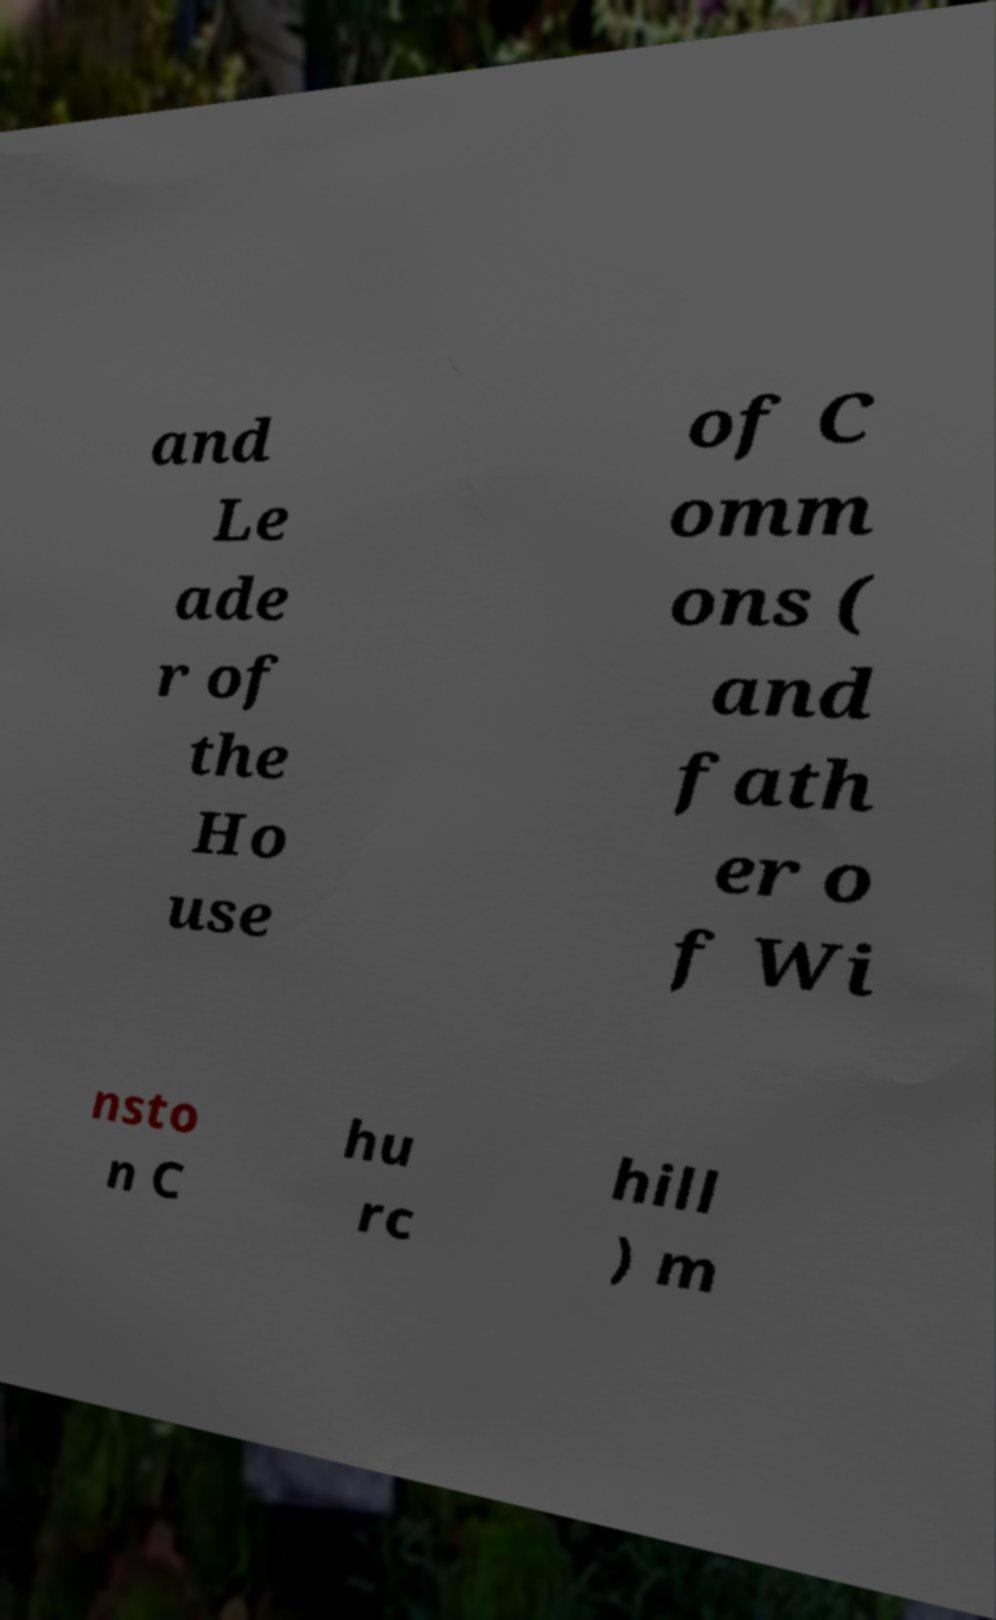I need the written content from this picture converted into text. Can you do that? and Le ade r of the Ho use of C omm ons ( and fath er o f Wi nsto n C hu rc hill ) m 